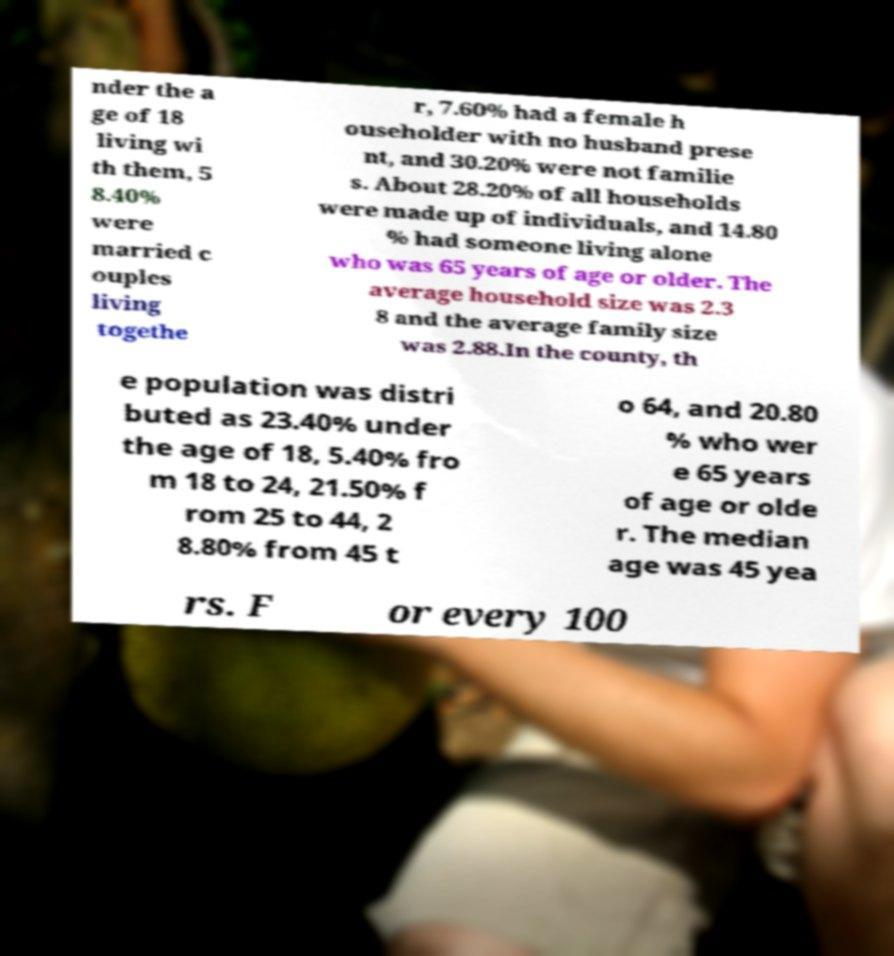There's text embedded in this image that I need extracted. Can you transcribe it verbatim? nder the a ge of 18 living wi th them, 5 8.40% were married c ouples living togethe r, 7.60% had a female h ouseholder with no husband prese nt, and 30.20% were not familie s. About 28.20% of all households were made up of individuals, and 14.80 % had someone living alone who was 65 years of age or older. The average household size was 2.3 8 and the average family size was 2.88.In the county, th e population was distri buted as 23.40% under the age of 18, 5.40% fro m 18 to 24, 21.50% f rom 25 to 44, 2 8.80% from 45 t o 64, and 20.80 % who wer e 65 years of age or olde r. The median age was 45 yea rs. F or every 100 